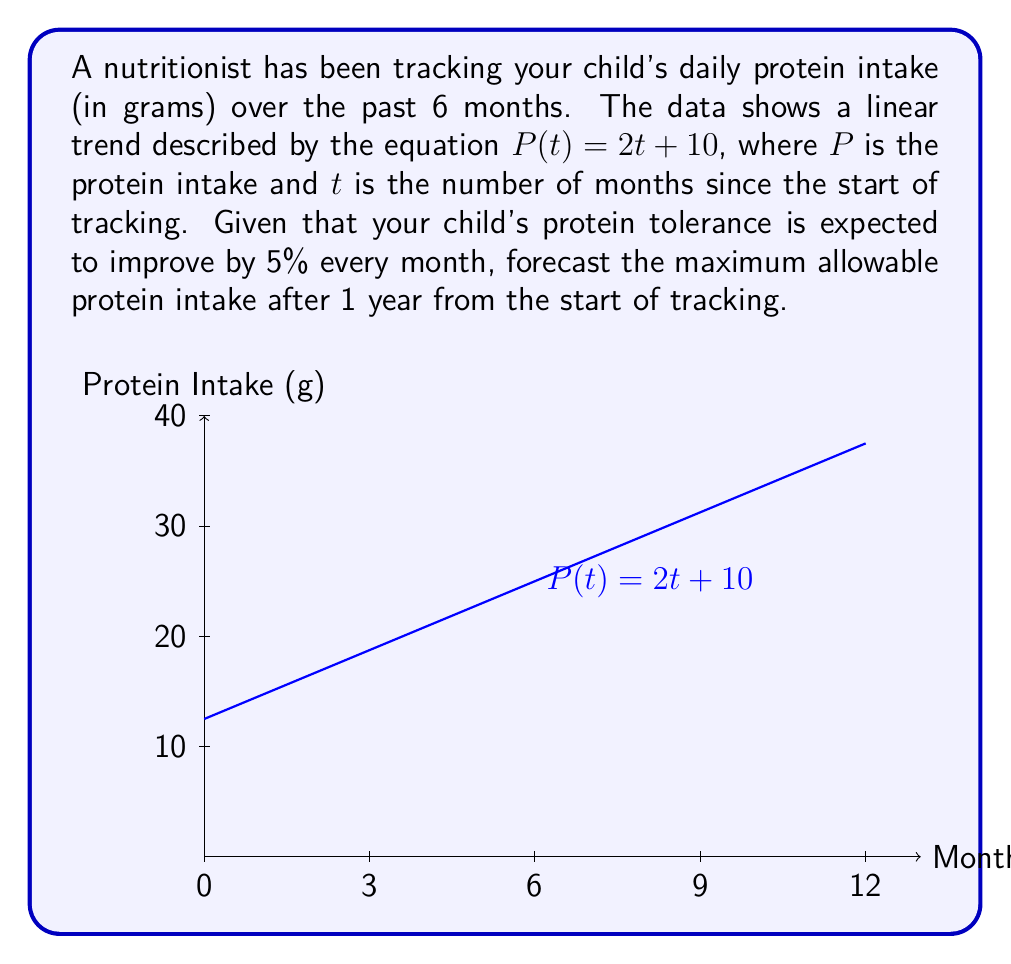Give your solution to this math problem. Let's approach this step-by-step:

1) First, we need to find the protein intake after 12 months using the given equation:
   $P(12) = 2(12) + 10 = 34$ grams

2) Now, we need to calculate the improvement in protein tolerance over 12 months:
   - Monthly improvement: 5%
   - Number of months: 12
   - Total improvement: $1.05^{12}$ (compound growth)

3) Calculate the total improvement factor:
   $1.05^{12} \approx 1.7958$ (rounded to 4 decimal places)

4) Apply this improvement factor to the protein intake at 12 months:
   Maximum allowable protein intake = $34 \times 1.7958 \approx 61.0572$ grams

5) Round to the nearest gram for practical purposes.
Answer: 61 grams 